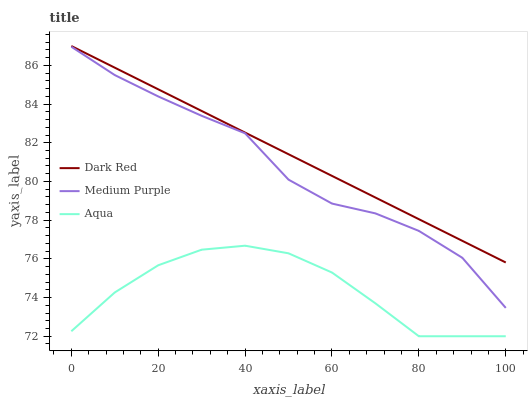Does Aqua have the minimum area under the curve?
Answer yes or no. Yes. Does Dark Red have the maximum area under the curve?
Answer yes or no. Yes. Does Dark Red have the minimum area under the curve?
Answer yes or no. No. Does Aqua have the maximum area under the curve?
Answer yes or no. No. Is Dark Red the smoothest?
Answer yes or no. Yes. Is Medium Purple the roughest?
Answer yes or no. Yes. Is Aqua the smoothest?
Answer yes or no. No. Is Aqua the roughest?
Answer yes or no. No. Does Aqua have the lowest value?
Answer yes or no. Yes. Does Dark Red have the lowest value?
Answer yes or no. No. Does Dark Red have the highest value?
Answer yes or no. Yes. Does Aqua have the highest value?
Answer yes or no. No. Is Medium Purple less than Dark Red?
Answer yes or no. Yes. Is Medium Purple greater than Aqua?
Answer yes or no. Yes. Does Medium Purple intersect Dark Red?
Answer yes or no. No. 